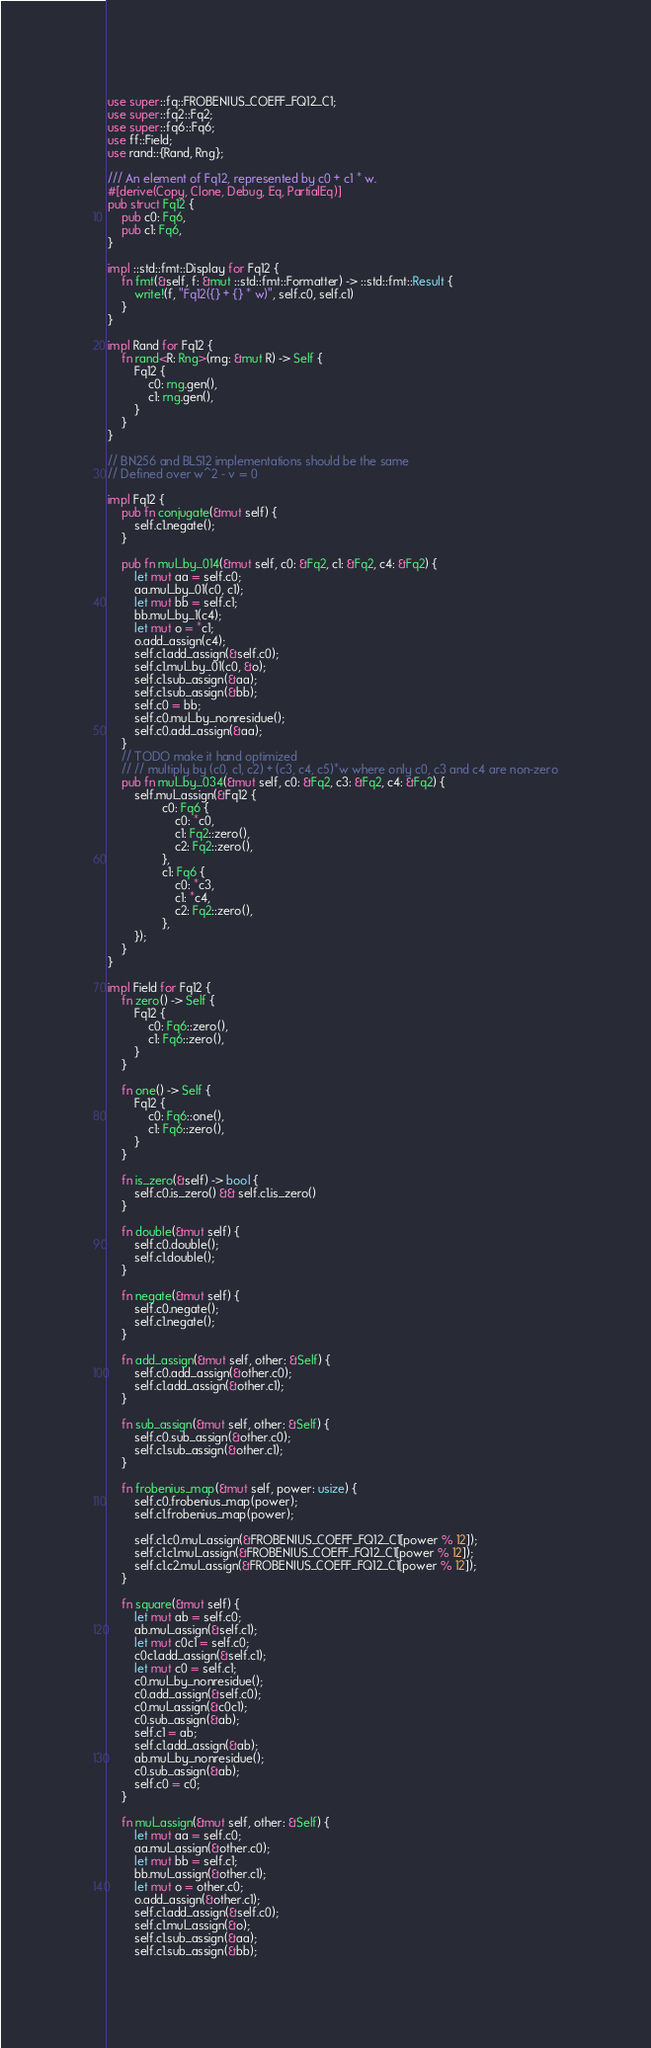Convert code to text. <code><loc_0><loc_0><loc_500><loc_500><_Rust_>use super::fq::FROBENIUS_COEFF_FQ12_C1;
use super::fq2::Fq2;
use super::fq6::Fq6;
use ff::Field;
use rand::{Rand, Rng};

/// An element of Fq12, represented by c0 + c1 * w.
#[derive(Copy, Clone, Debug, Eq, PartialEq)]
pub struct Fq12 {
    pub c0: Fq6,
    pub c1: Fq6,
}

impl ::std::fmt::Display for Fq12 {
    fn fmt(&self, f: &mut ::std::fmt::Formatter) -> ::std::fmt::Result {
        write!(f, "Fq12({} + {} * w)", self.c0, self.c1)
    }
}

impl Rand for Fq12 {
    fn rand<R: Rng>(rng: &mut R) -> Self {
        Fq12 {
            c0: rng.gen(),
            c1: rng.gen(),
        }
    }
}

// BN256 and BLS12 implementations should be the same
// Defined over w^2 - v = 0

impl Fq12 {
    pub fn conjugate(&mut self) {
        self.c1.negate();
    }

    pub fn mul_by_014(&mut self, c0: &Fq2, c1: &Fq2, c4: &Fq2) {
        let mut aa = self.c0;
        aa.mul_by_01(c0, c1);
        let mut bb = self.c1;
        bb.mul_by_1(c4);
        let mut o = *c1;
        o.add_assign(c4);
        self.c1.add_assign(&self.c0);
        self.c1.mul_by_01(c0, &o);
        self.c1.sub_assign(&aa);
        self.c1.sub_assign(&bb);
        self.c0 = bb;
        self.c0.mul_by_nonresidue();
        self.c0.add_assign(&aa);
    }
    // TODO make it hand optimized
    // // multiply by (c0, c1, c2) + (c3, c4, c5)*w where only c0, c3 and c4 are non-zero
    pub fn mul_by_034(&mut self, c0: &Fq2, c3: &Fq2, c4: &Fq2) {
        self.mul_assign(&Fq12 {
                c0: Fq6 {
                    c0: *c0,
                    c1: Fq2::zero(),
                    c2: Fq2::zero(),
                },
                c1: Fq6 {
                    c0: *c3,
                    c1: *c4,
                    c2: Fq2::zero(),
                },
        });
    }
}

impl Field for Fq12 {
    fn zero() -> Self {
        Fq12 {
            c0: Fq6::zero(),
            c1: Fq6::zero(),
        }
    }

    fn one() -> Self {
        Fq12 {
            c0: Fq6::one(),
            c1: Fq6::zero(),
        }
    }

    fn is_zero(&self) -> bool {
        self.c0.is_zero() && self.c1.is_zero()
    }

    fn double(&mut self) {
        self.c0.double();
        self.c1.double();
    }

    fn negate(&mut self) {
        self.c0.negate();
        self.c1.negate();
    }

    fn add_assign(&mut self, other: &Self) {
        self.c0.add_assign(&other.c0);
        self.c1.add_assign(&other.c1);
    }

    fn sub_assign(&mut self, other: &Self) {
        self.c0.sub_assign(&other.c0);
        self.c1.sub_assign(&other.c1);
    }

    fn frobenius_map(&mut self, power: usize) {
        self.c0.frobenius_map(power);
        self.c1.frobenius_map(power);

        self.c1.c0.mul_assign(&FROBENIUS_COEFF_FQ12_C1[power % 12]);
        self.c1.c1.mul_assign(&FROBENIUS_COEFF_FQ12_C1[power % 12]);
        self.c1.c2.mul_assign(&FROBENIUS_COEFF_FQ12_C1[power % 12]);
    }

    fn square(&mut self) {
        let mut ab = self.c0;
        ab.mul_assign(&self.c1);
        let mut c0c1 = self.c0;
        c0c1.add_assign(&self.c1);
        let mut c0 = self.c1;
        c0.mul_by_nonresidue();
        c0.add_assign(&self.c0);
        c0.mul_assign(&c0c1);
        c0.sub_assign(&ab);
        self.c1 = ab;
        self.c1.add_assign(&ab);
        ab.mul_by_nonresidue();
        c0.sub_assign(&ab);
        self.c0 = c0;
    }

    fn mul_assign(&mut self, other: &Self) {
        let mut aa = self.c0;
        aa.mul_assign(&other.c0);
        let mut bb = self.c1;
        bb.mul_assign(&other.c1);
        let mut o = other.c0;
        o.add_assign(&other.c1);
        self.c1.add_assign(&self.c0);
        self.c1.mul_assign(&o);
        self.c1.sub_assign(&aa);
        self.c1.sub_assign(&bb);</code> 